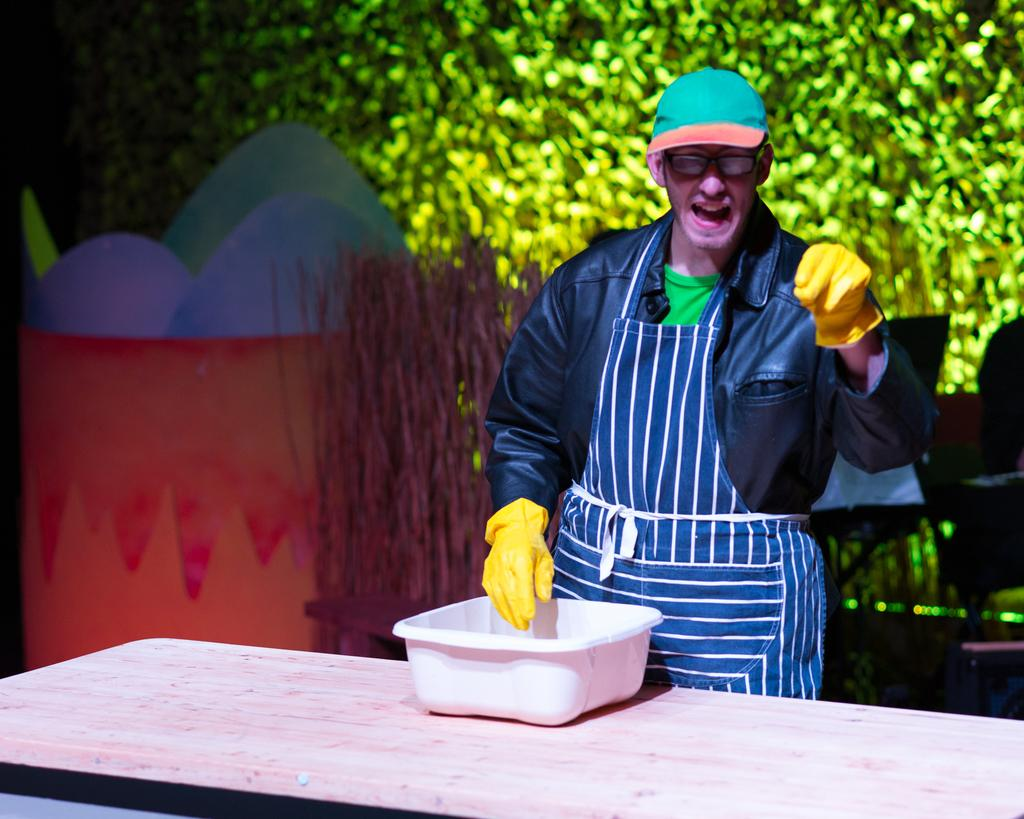Who is present in the image? There is a man in the image. What is the man doing in the image? The man is standing at a table. What object is on the table in the image? There is a small tub on the table. What type of basket is hanging from the ceiling in the image? There is no basket hanging from the ceiling in the image; it only features a man standing at a table with a small tub. 